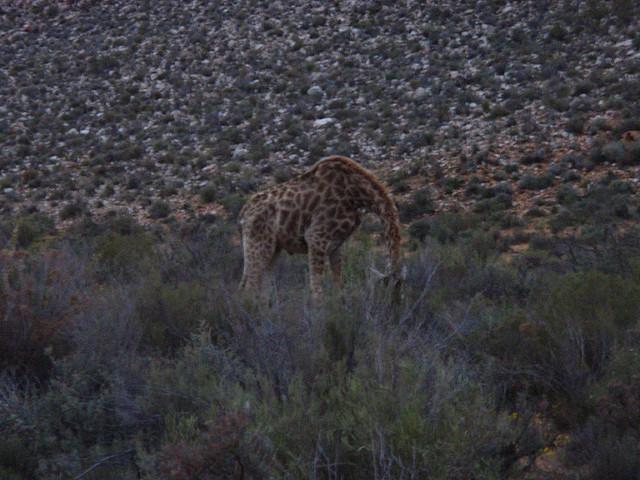What type of animal is in this picture?
Keep it brief. Giraffe. Is the grass green?
Quick response, please. Yes. Is the animal standing on a rock?
Short answer required. No. How tall is the giraffe?
Write a very short answer. 10 feet. What colors are on this animal?
Short answer required. Brown. What type of animals are in the field?
Be succinct. Giraffe. Are these fully grown?
Concise answer only. Yes. Is this created during the daytime?
Concise answer only. No. Is there a shadow?
Concise answer only. No. What is the animal in the picture doing?
Write a very short answer. Eating. What animal is in the bush?
Be succinct. Giraffe. How many green patches of grass are there?
Answer briefly. 0. Is this a family?
Answer briefly. No. What type of animal is this?
Keep it brief. Giraffe. What animal is this?
Concise answer only. Giraffe. 